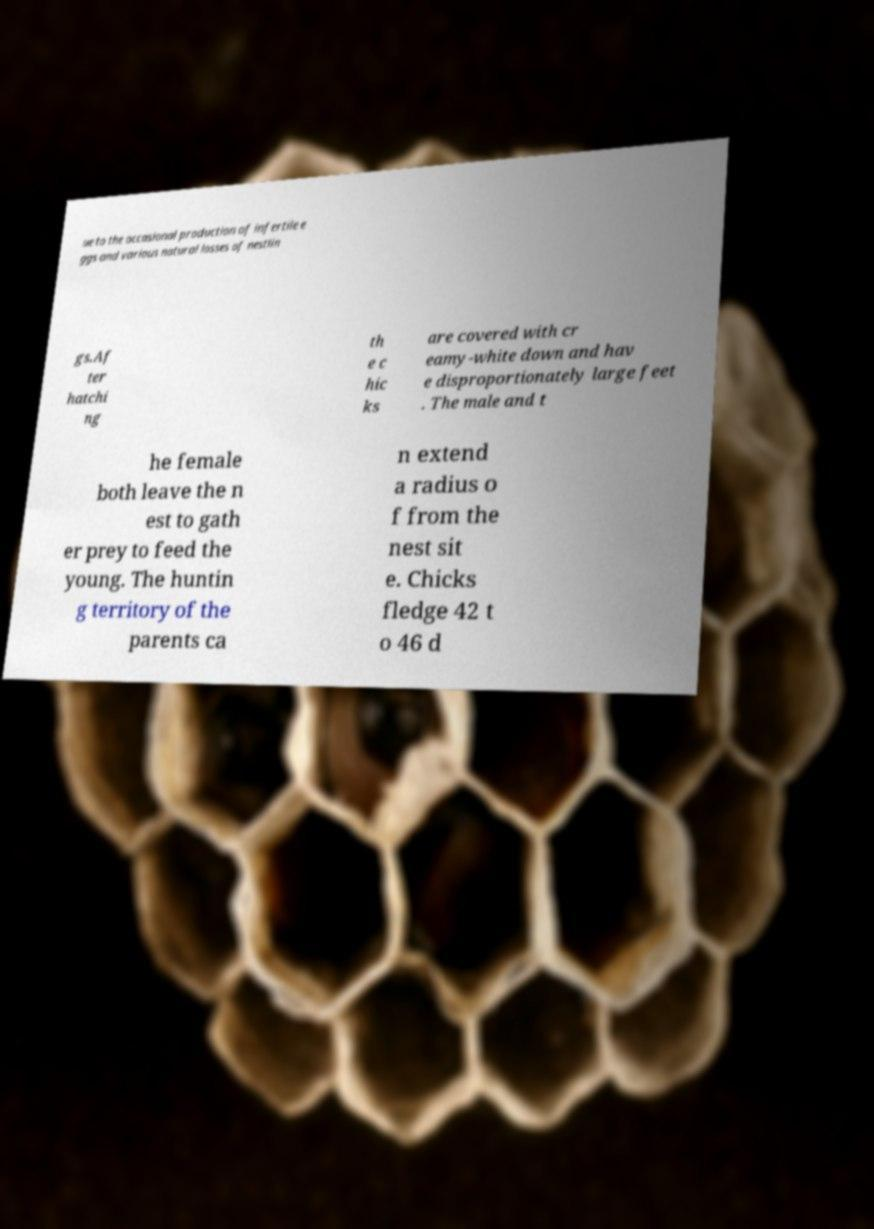For documentation purposes, I need the text within this image transcribed. Could you provide that? ue to the occasional production of infertile e ggs and various natural losses of nestlin gs.Af ter hatchi ng th e c hic ks are covered with cr eamy-white down and hav e disproportionately large feet . The male and t he female both leave the n est to gath er prey to feed the young. The huntin g territory of the parents ca n extend a radius o f from the nest sit e. Chicks fledge 42 t o 46 d 